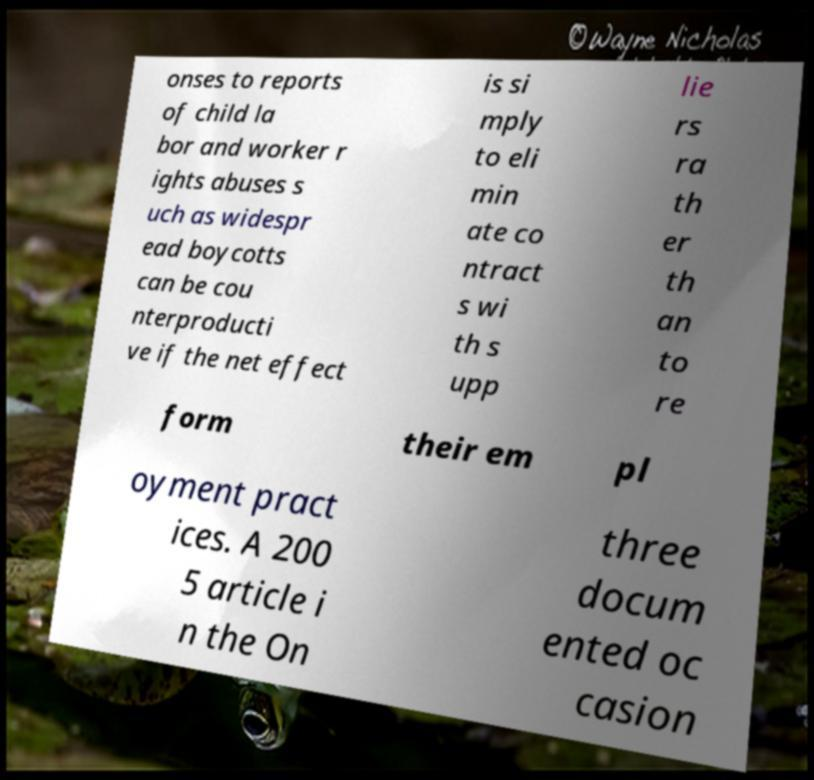There's text embedded in this image that I need extracted. Can you transcribe it verbatim? onses to reports of child la bor and worker r ights abuses s uch as widespr ead boycotts can be cou nterproducti ve if the net effect is si mply to eli min ate co ntract s wi th s upp lie rs ra th er th an to re form their em pl oyment pract ices. A 200 5 article i n the On three docum ented oc casion 